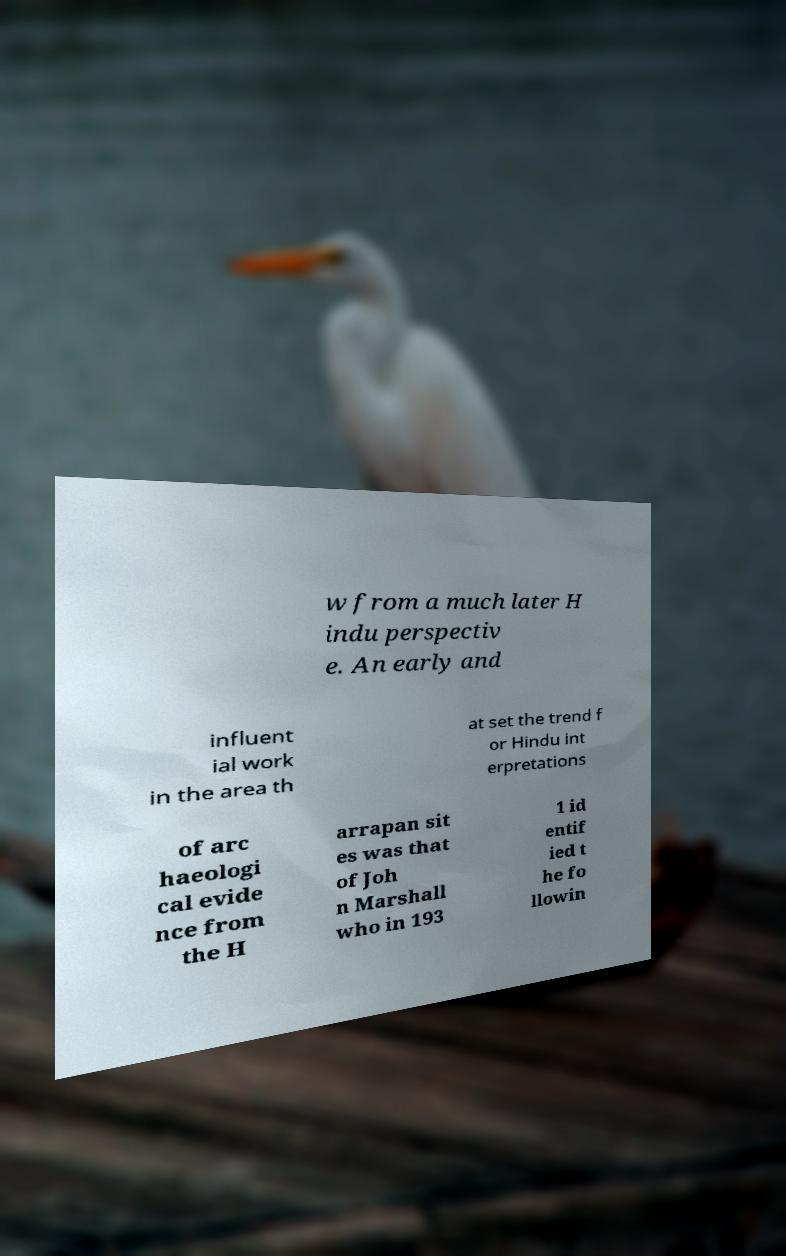Can you read and provide the text displayed in the image?This photo seems to have some interesting text. Can you extract and type it out for me? w from a much later H indu perspectiv e. An early and influent ial work in the area th at set the trend f or Hindu int erpretations of arc haeologi cal evide nce from the H arrapan sit es was that of Joh n Marshall who in 193 1 id entif ied t he fo llowin 